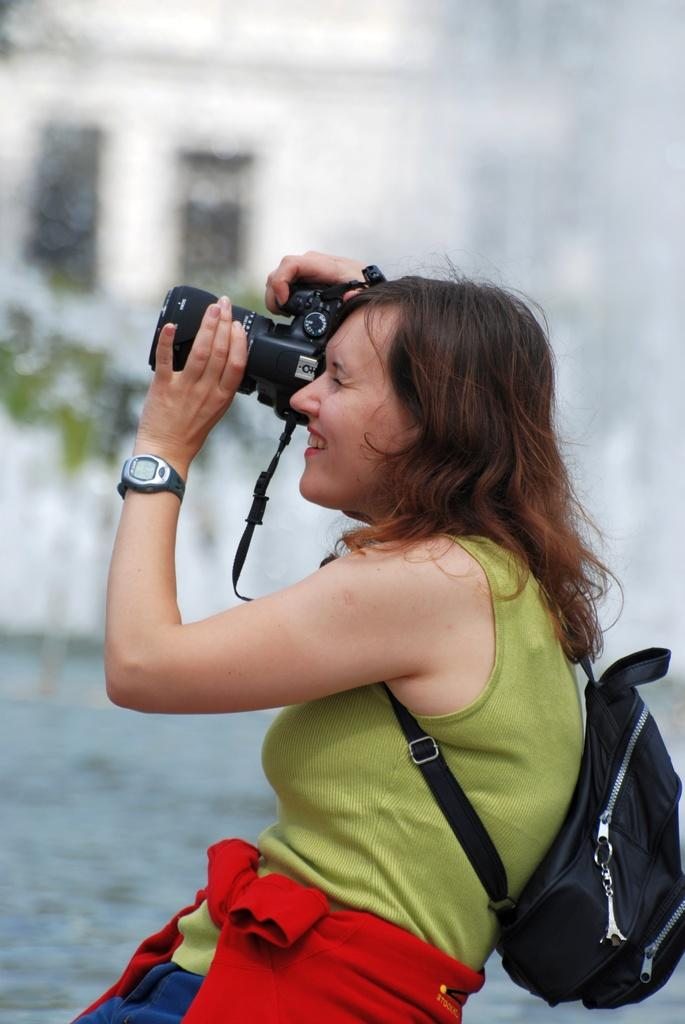Who is the main subject in the image? There is a woman in the image. What color is the bag the woman is wearing? The woman is wearing a black color bag. What color is the t-shirt the woman is wearing? The woman is wearing a green color t-shirt. What type of accessory is the woman wearing on her wrist? The woman is wearing a brown color watch. What is the woman holding in her hand? The woman is holding a camera in her hand. How would you describe the background of the image? The background of the image is blurry. What type of ring can be seen on the woman's throat in the image? There is no ring visible on the woman's throat in the image. 